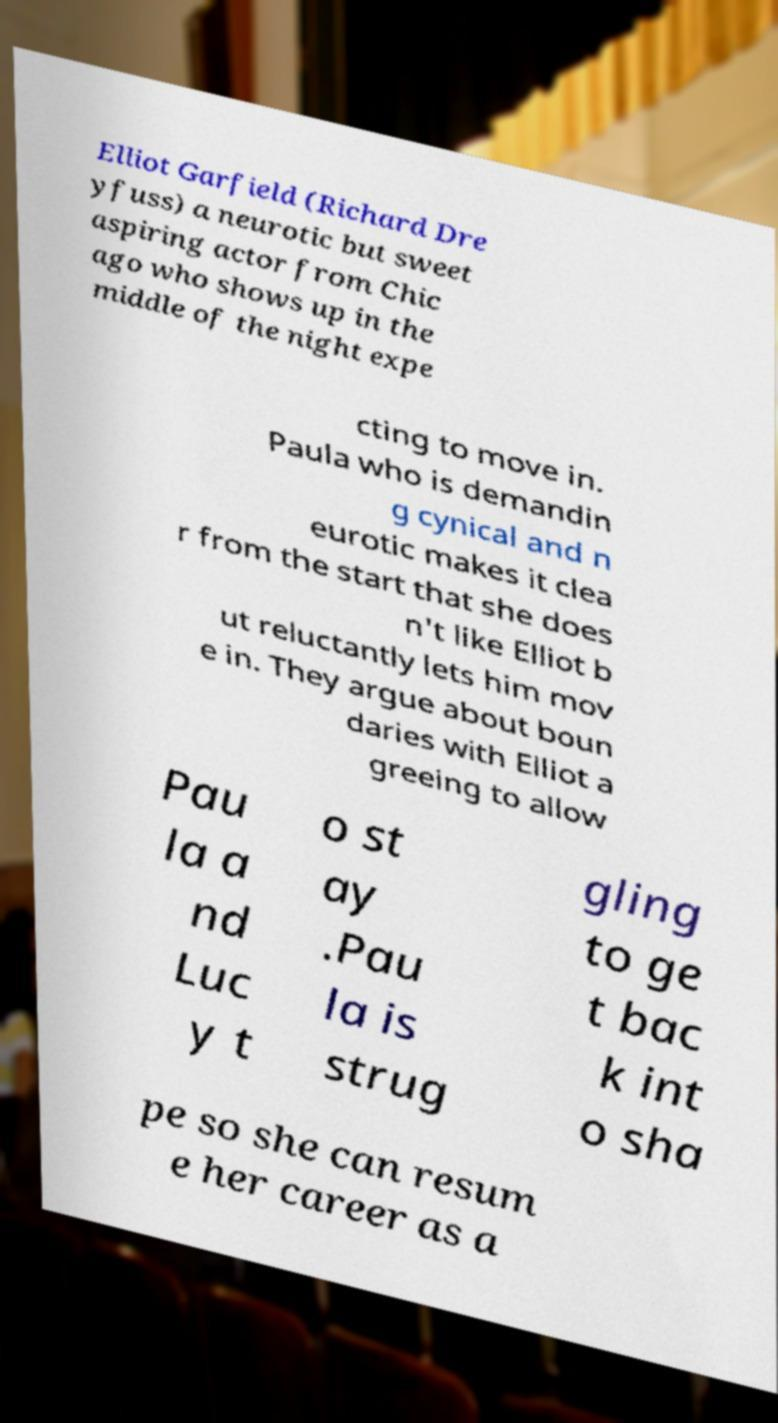Please read and relay the text visible in this image. What does it say? Elliot Garfield (Richard Dre yfuss) a neurotic but sweet aspiring actor from Chic ago who shows up in the middle of the night expe cting to move in. Paula who is demandin g cynical and n eurotic makes it clea r from the start that she does n't like Elliot b ut reluctantly lets him mov e in. They argue about boun daries with Elliot a greeing to allow Pau la a nd Luc y t o st ay .Pau la is strug gling to ge t bac k int o sha pe so she can resum e her career as a 